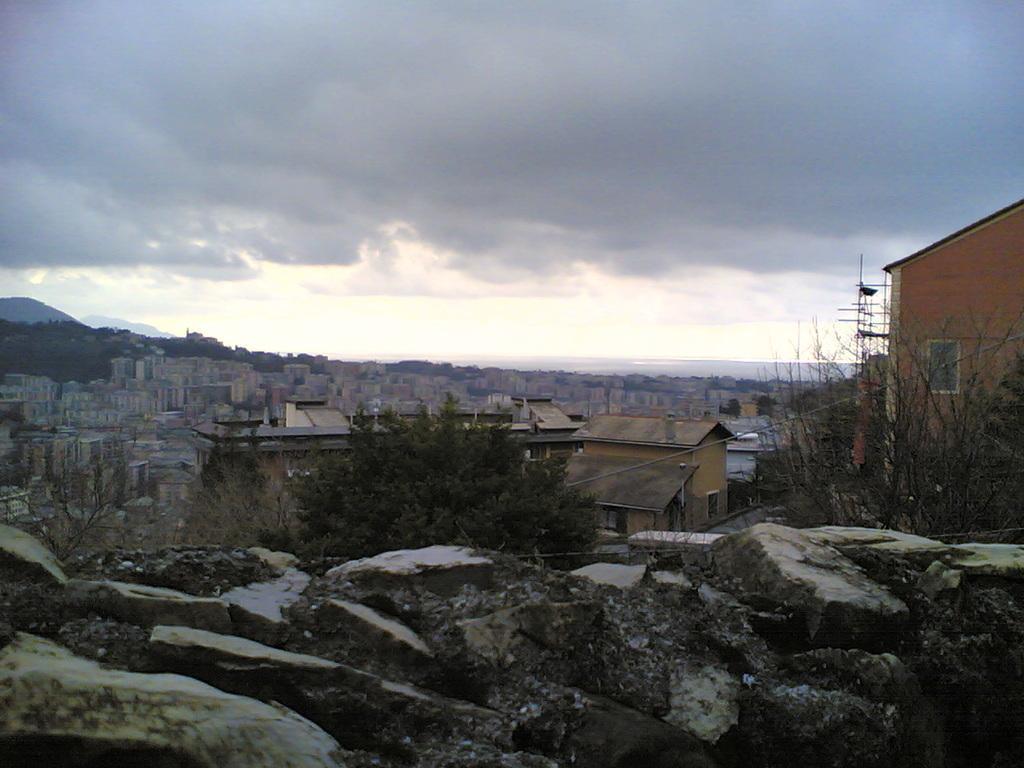Can you describe this image briefly? In this image, there is an outside view. There are some buildings in the middle of the image. There is a tree beside rocks. In the background of the image, there is a sky. 